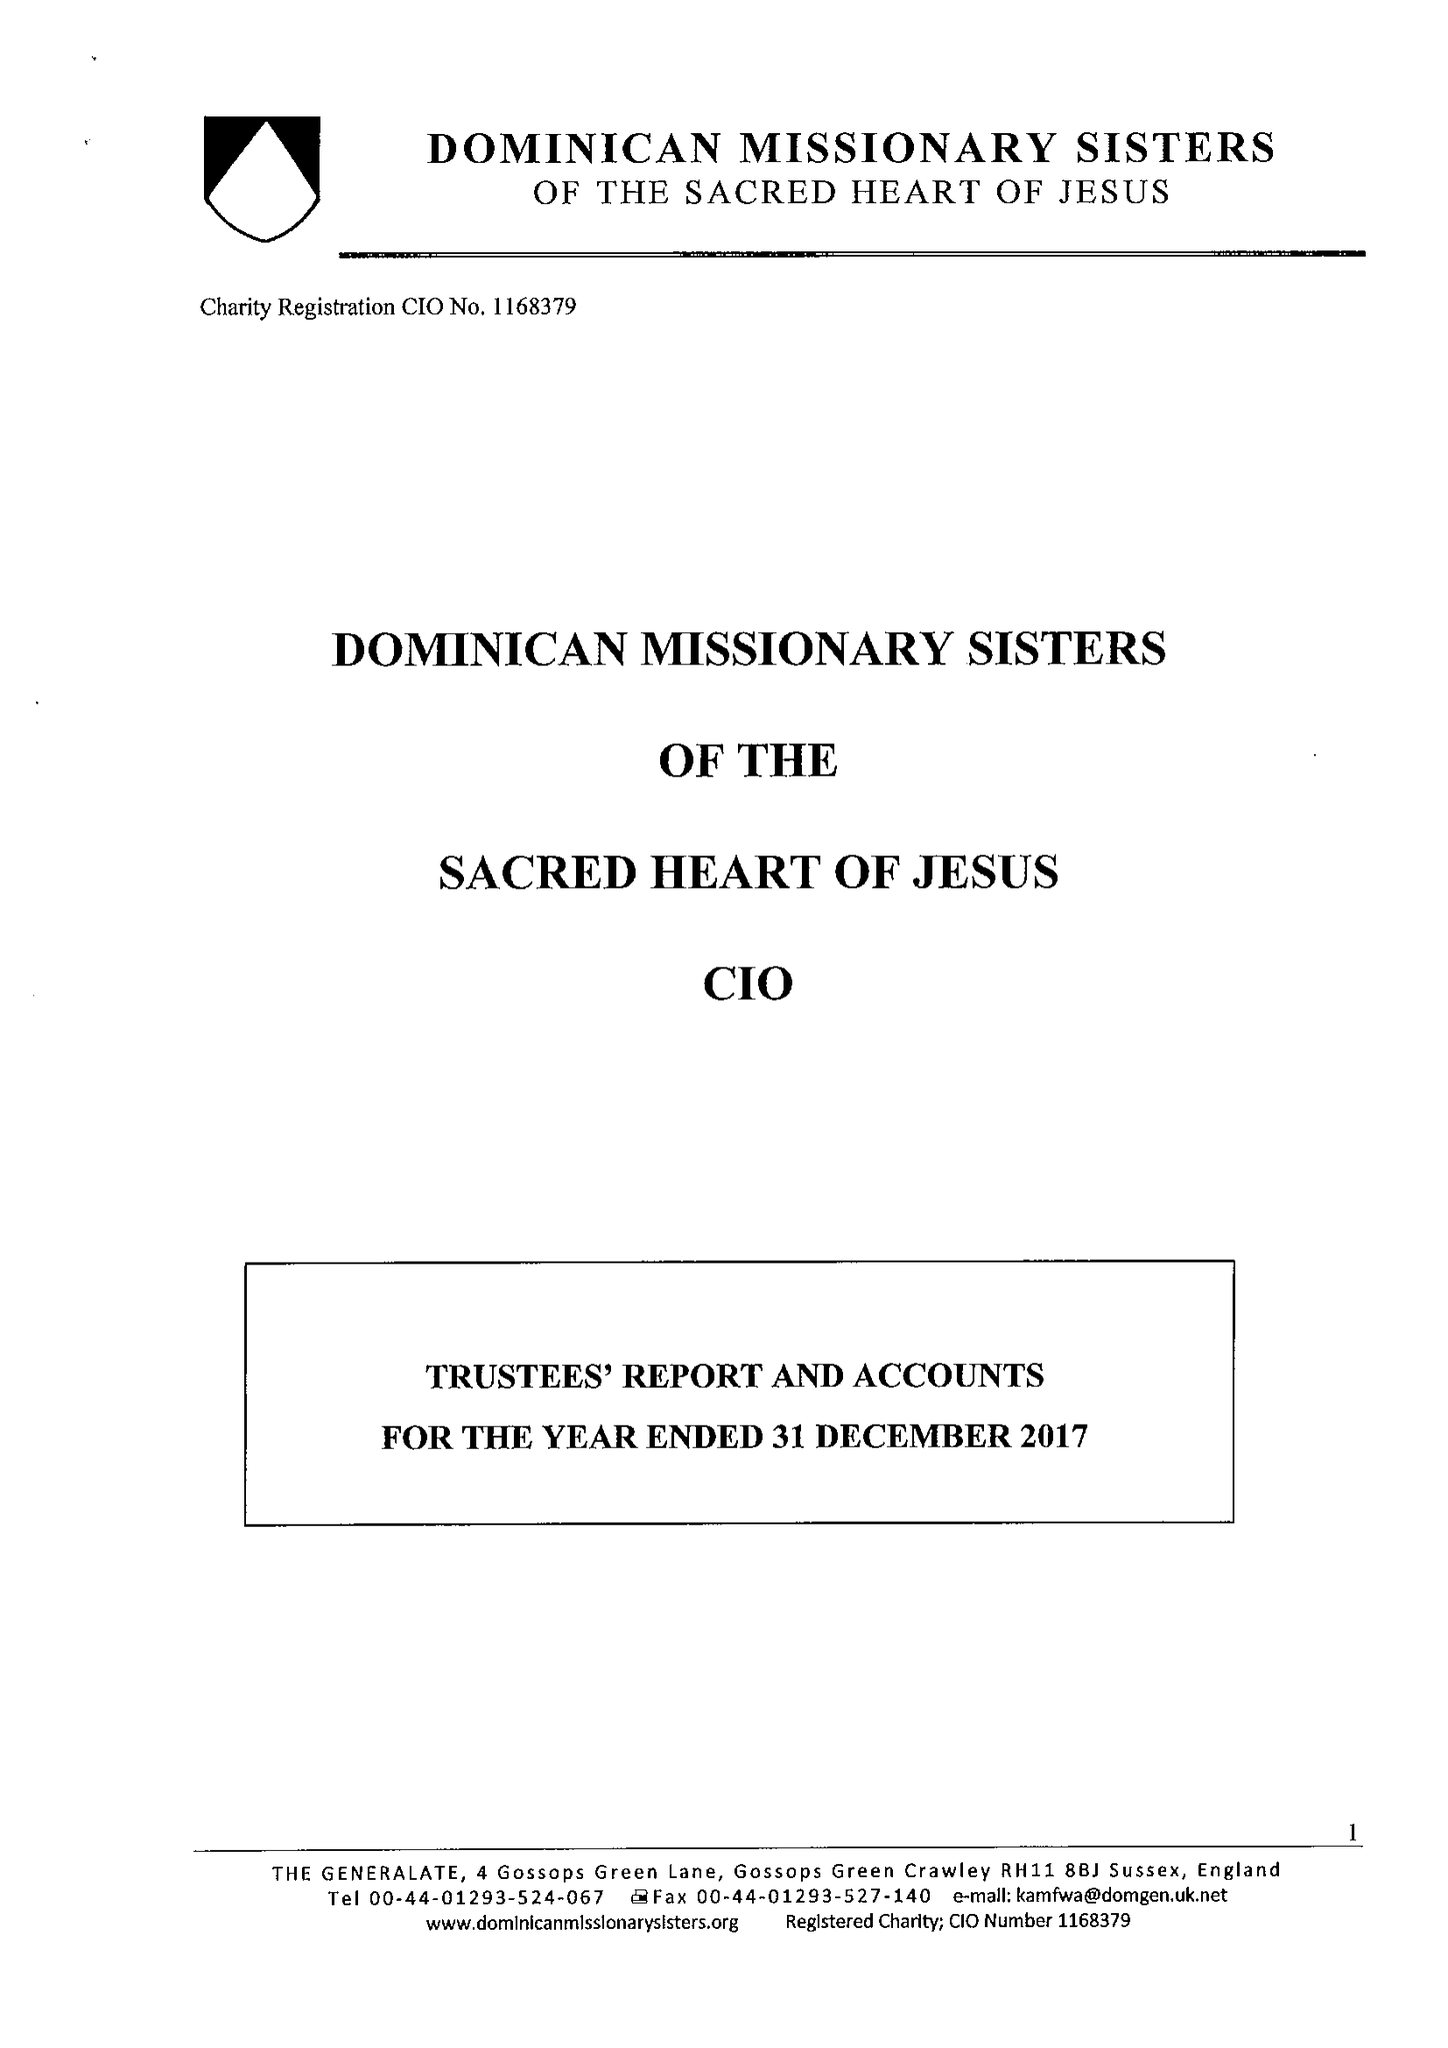What is the value for the address__post_town?
Answer the question using a single word or phrase. CRAWLEY 